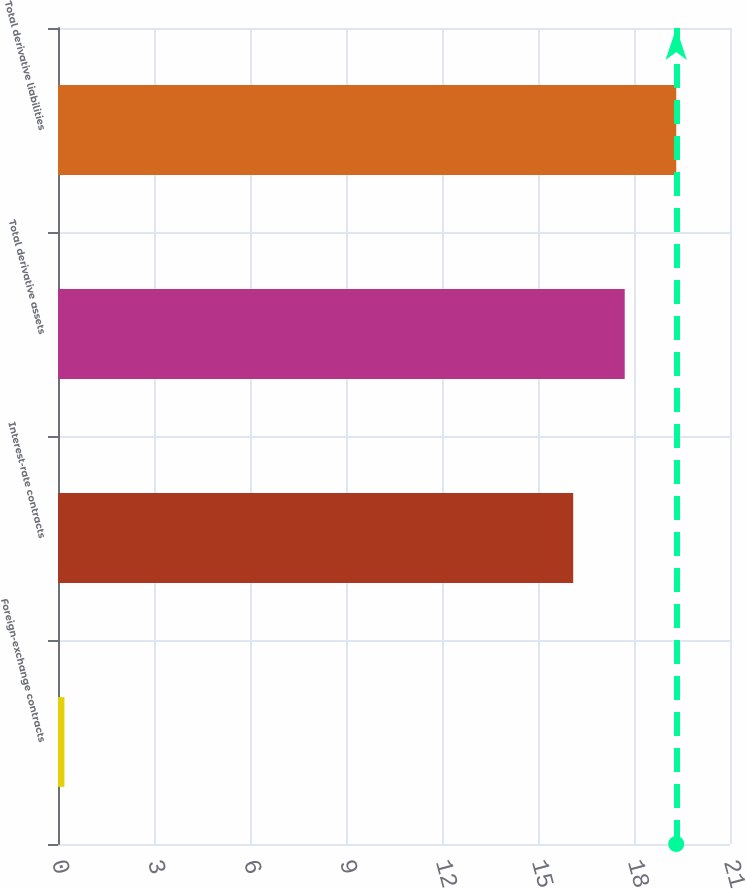Convert chart. <chart><loc_0><loc_0><loc_500><loc_500><bar_chart><fcel>Foreign-exchange contracts<fcel>Interest-rate contracts<fcel>Total derivative assets<fcel>Total derivative liabilities<nl><fcel>0.2<fcel>16.1<fcel>17.71<fcel>19.32<nl></chart> 